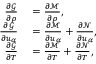<formula> <loc_0><loc_0><loc_500><loc_500>\begin{array} { r l } { \frac { \partial \mathcal { G } } { \partial \rho } } & = \frac { \partial \mathcal { M } } { \partial \rho } , } \\ { \frac { \partial \mathcal { G } } { \partial u _ { \alpha } } } & = \frac { \partial \mathcal { M } } { \partial u _ { \alpha } } + \frac { \partial \mathcal { N } } { \partial u _ { \alpha } } , } \\ { \frac { \partial \mathcal { G } } { \partial T } } & = \frac { \partial \mathcal { M } } { \partial T } + \frac { \partial \mathcal { N } } { \partial T } , } \end{array}</formula> 